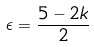<formula> <loc_0><loc_0><loc_500><loc_500>\epsilon = \frac { 5 - 2 k } { 2 }</formula> 